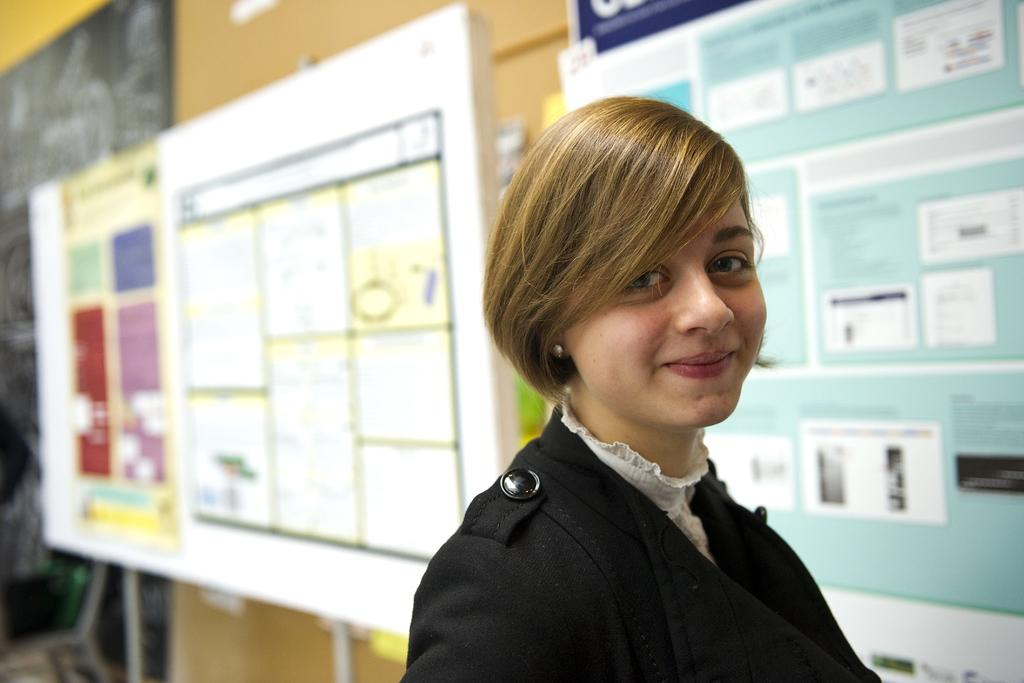Who or what is present in the image? There is a person in the image. What is the person wearing? The person is wearing clothes. What can be seen on the wall in the image? There are boards in front of a wall in the image. What type of account does the zebra have in the image? There is no zebra present in the image, so it is not possible to determine if it has an account or not. 